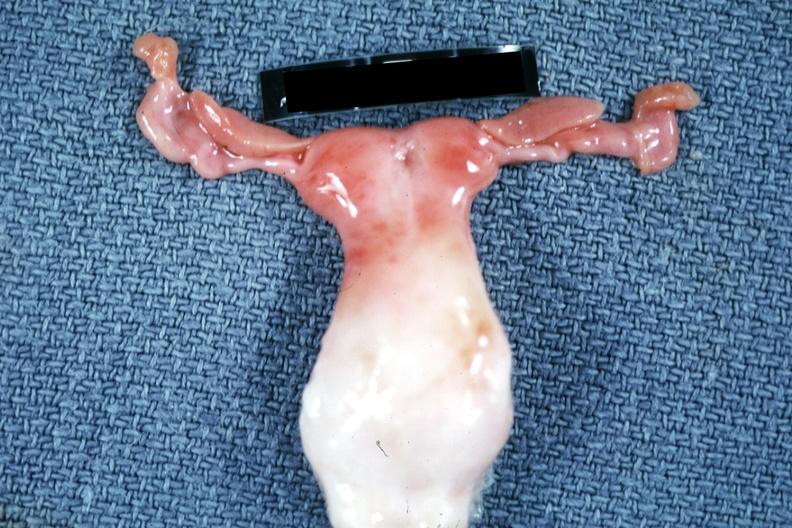s bicornate uterus present?
Answer the question using a single word or phrase. Yes 